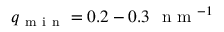Convert formula to latex. <formula><loc_0><loc_0><loc_500><loc_500>q _ { m i n } = 0 . 2 - 0 . 3 \ n m ^ { - 1 }</formula> 